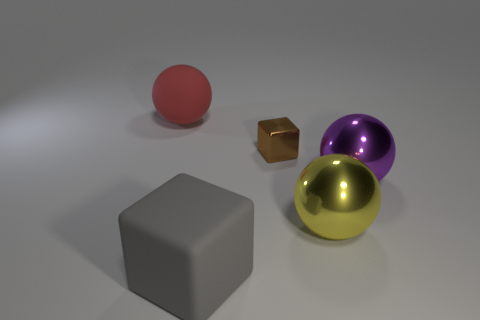Subtract all large purple shiny balls. How many balls are left? 2 Add 1 purple spheres. How many objects exist? 6 Subtract all red spheres. How many spheres are left? 2 Subtract all blocks. How many objects are left? 3 Subtract all green spheres. Subtract all blue blocks. How many spheres are left? 3 Subtract 0 cyan blocks. How many objects are left? 5 Subtract all purple matte objects. Subtract all purple spheres. How many objects are left? 4 Add 2 tiny things. How many tiny things are left? 3 Add 3 small blue metal spheres. How many small blue metal spheres exist? 3 